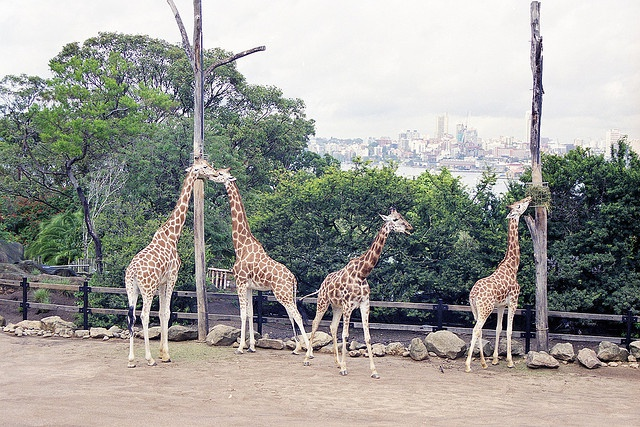Describe the objects in this image and their specific colors. I can see giraffe in white, lightgray, darkgray, tan, and gray tones, giraffe in white, lightgray, brown, darkgray, and tan tones, giraffe in white, lightgray, darkgray, tan, and gray tones, and giraffe in white, lightgray, tan, gray, and darkgray tones in this image. 